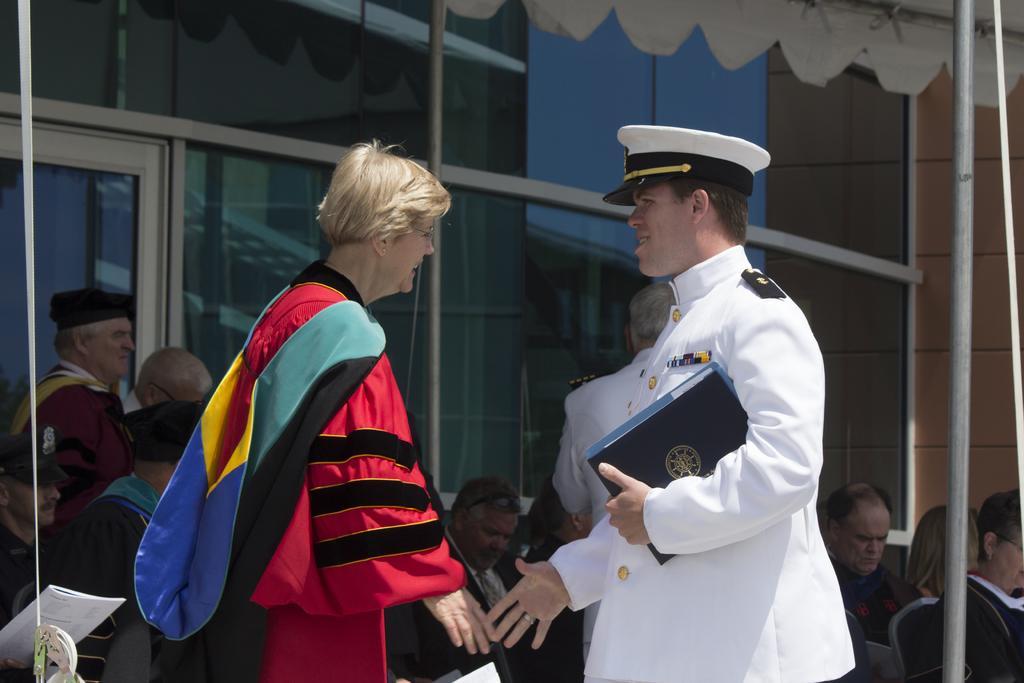Describe this image in one or two sentences. In this image we can see a man on the right side and holding a book in his hands and on the left side we can see a woman. In the background there are few persons, glass doors, poles, wall and at the top we can see a tent. On the left side we can see a book in a person's hand. 